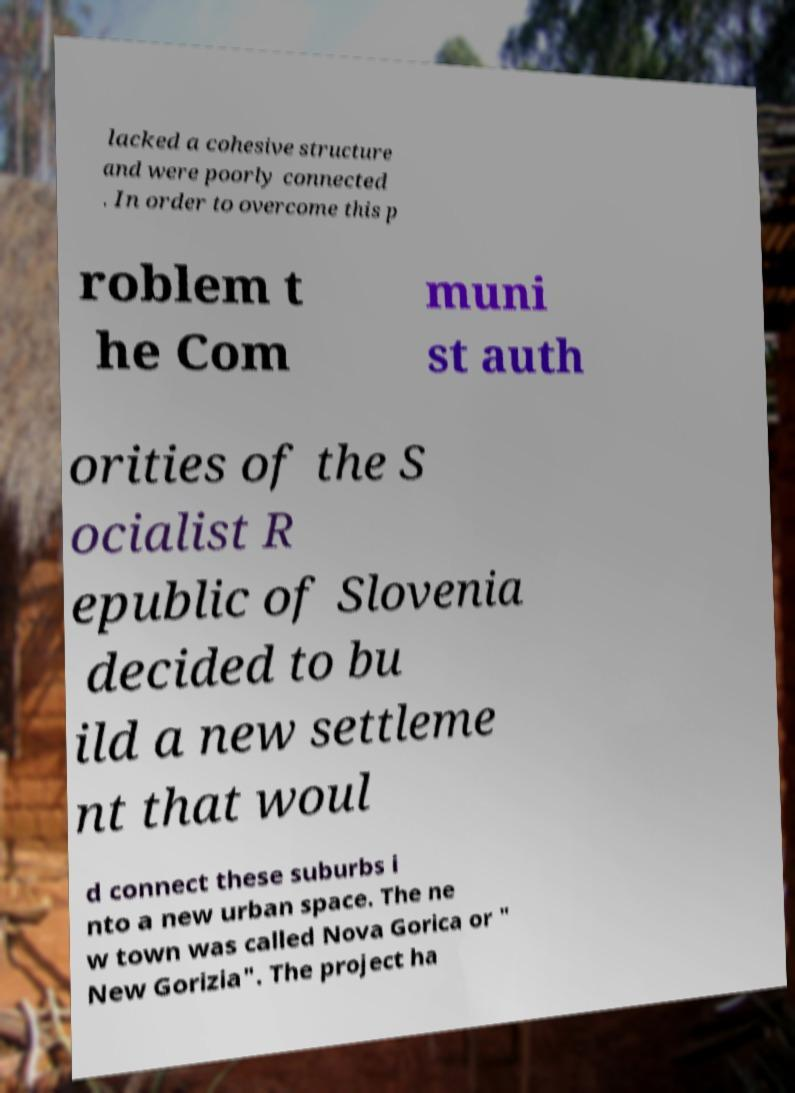I need the written content from this picture converted into text. Can you do that? lacked a cohesive structure and were poorly connected . In order to overcome this p roblem t he Com muni st auth orities of the S ocialist R epublic of Slovenia decided to bu ild a new settleme nt that woul d connect these suburbs i nto a new urban space. The ne w town was called Nova Gorica or " New Gorizia". The project ha 